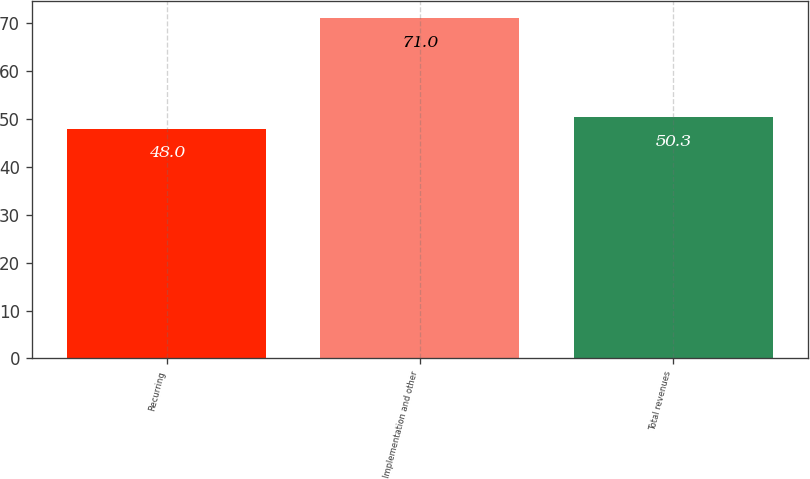Convert chart. <chart><loc_0><loc_0><loc_500><loc_500><bar_chart><fcel>Recurring<fcel>Implementation and other<fcel>Total revenues<nl><fcel>48<fcel>71<fcel>50.3<nl></chart> 